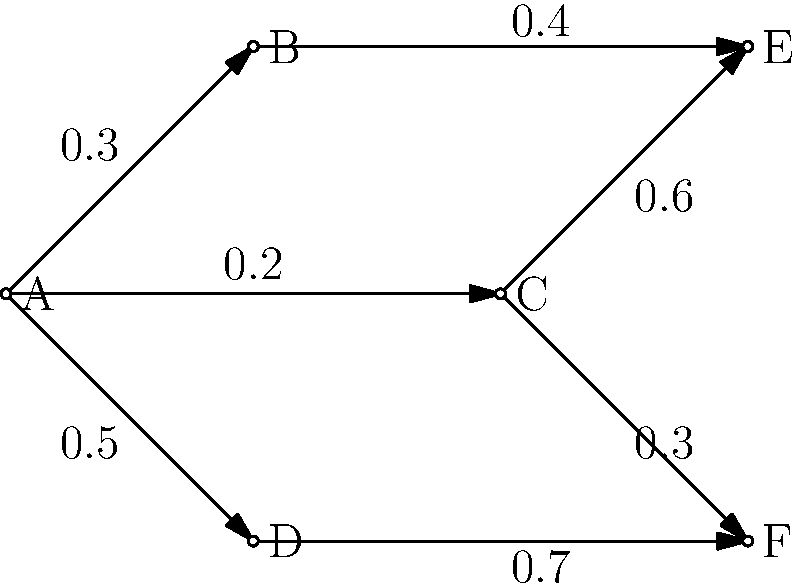The network graph represents an investment portfolio where nodes are asset classes and edges show the flow of investments with their respective weights. What is the total weight of investments flowing into node E, and what does this imply about the portfolio's diversification? To solve this problem, we need to follow these steps:

1. Identify the nodes that have edges pointing to node E.
   From the graph, we can see that nodes B and C have edges pointing to E.

2. Sum the weights of these edges:
   - Edge from B to E: 0.4
   - Edge from C to E: 0.6

3. Calculate the total weight:
   $0.4 + 0.6 = 1.0$

4. Interpret the result:
   The total weight of 1.0 (or 100%) flowing into node E implies that all investments from B and C are directed solely to E. This suggests a lack of diversification for the investments originating from B and C, as they are concentrated in a single asset class (E).

5. Consider the implications for portfolio diversification:
   - High concentration in E increases risk if E underperforms
   - Limited spread of investments from B and C reduces the benefits of diversification
   - The portfolio might benefit from redistributing some investments to other asset classes

This analysis highlights the importance of evaluating investment flows and concentrations in portfolio management to ensure proper diversification and risk management.
Answer: Total weight: 1.0; Implies poor diversification for investments from B and C. 